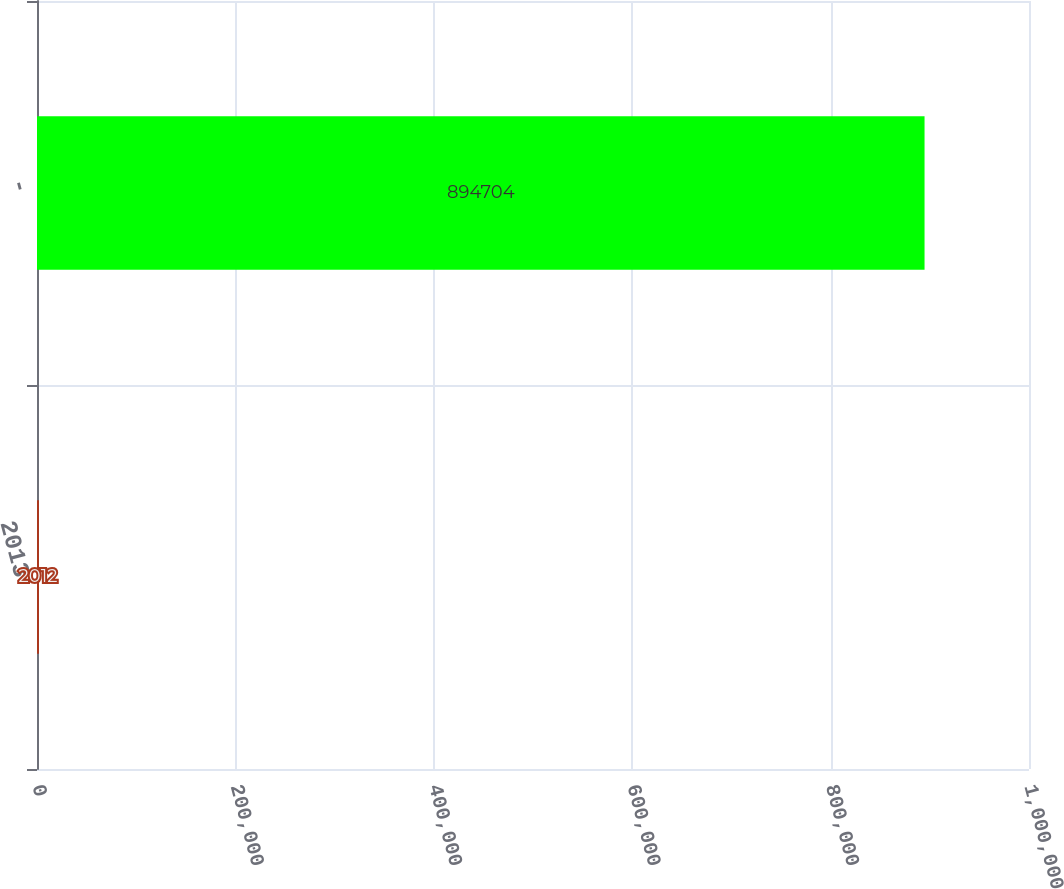Convert chart to OTSL. <chart><loc_0><loc_0><loc_500><loc_500><bar_chart><fcel>2013<fcel>-<nl><fcel>2012<fcel>894704<nl></chart> 